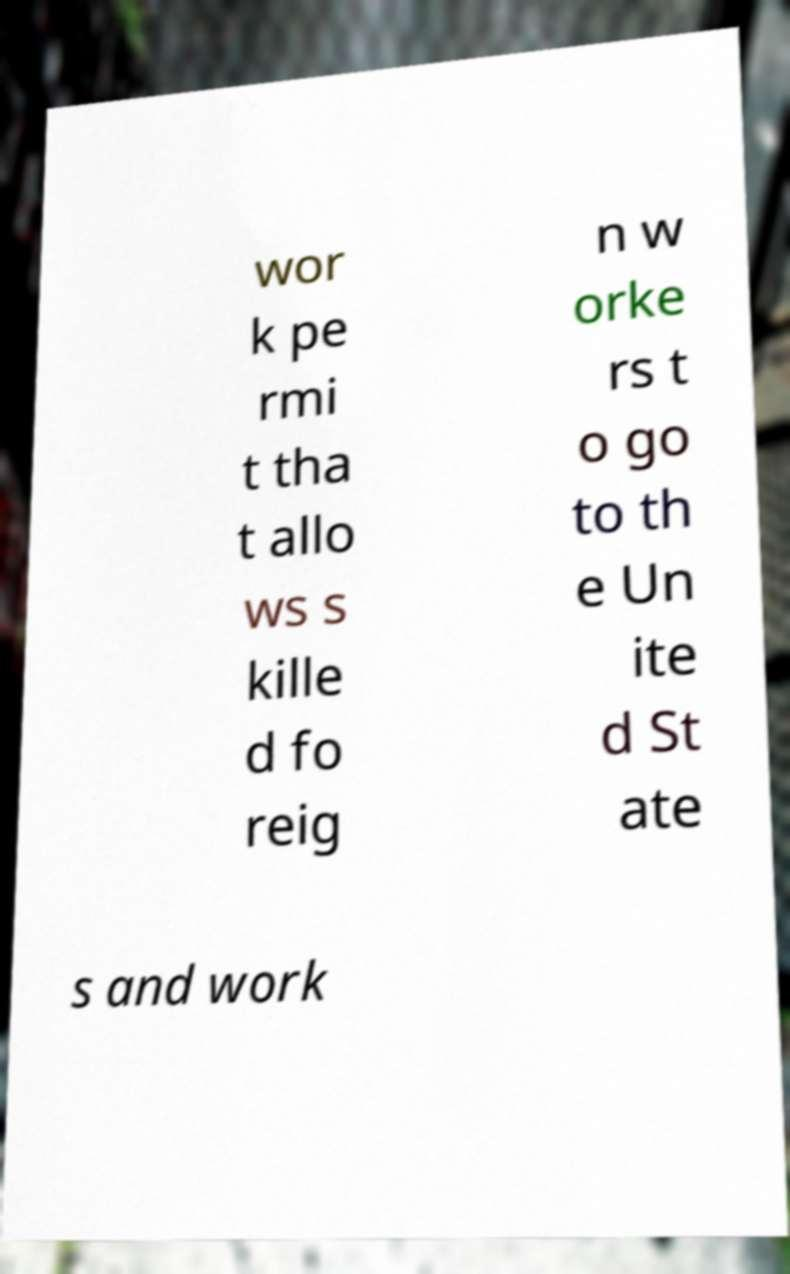I need the written content from this picture converted into text. Can you do that? wor k pe rmi t tha t allo ws s kille d fo reig n w orke rs t o go to th e Un ite d St ate s and work 